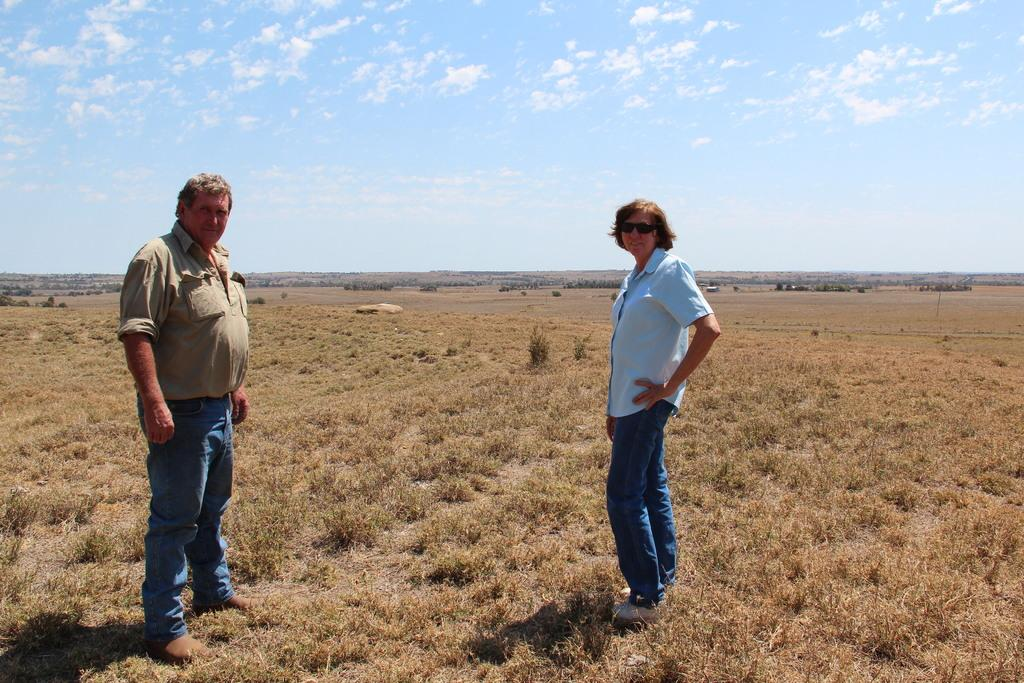How many people are in the image? There are a few people in the image. What is visible beneath the people's feet? The ground is visible in the image. What type of vegetation can be seen in the image? There is grass and plants in the image. What other object can be seen in the image? There is a rock in the image. What is visible above the people's heads? The sky is visible in the image. What can be seen in the sky? Clouds are present in the sky. What type of pail is being used to educate the cows in the image? There are no cows or pails present in the image, and therefore no such activity can be observed. 